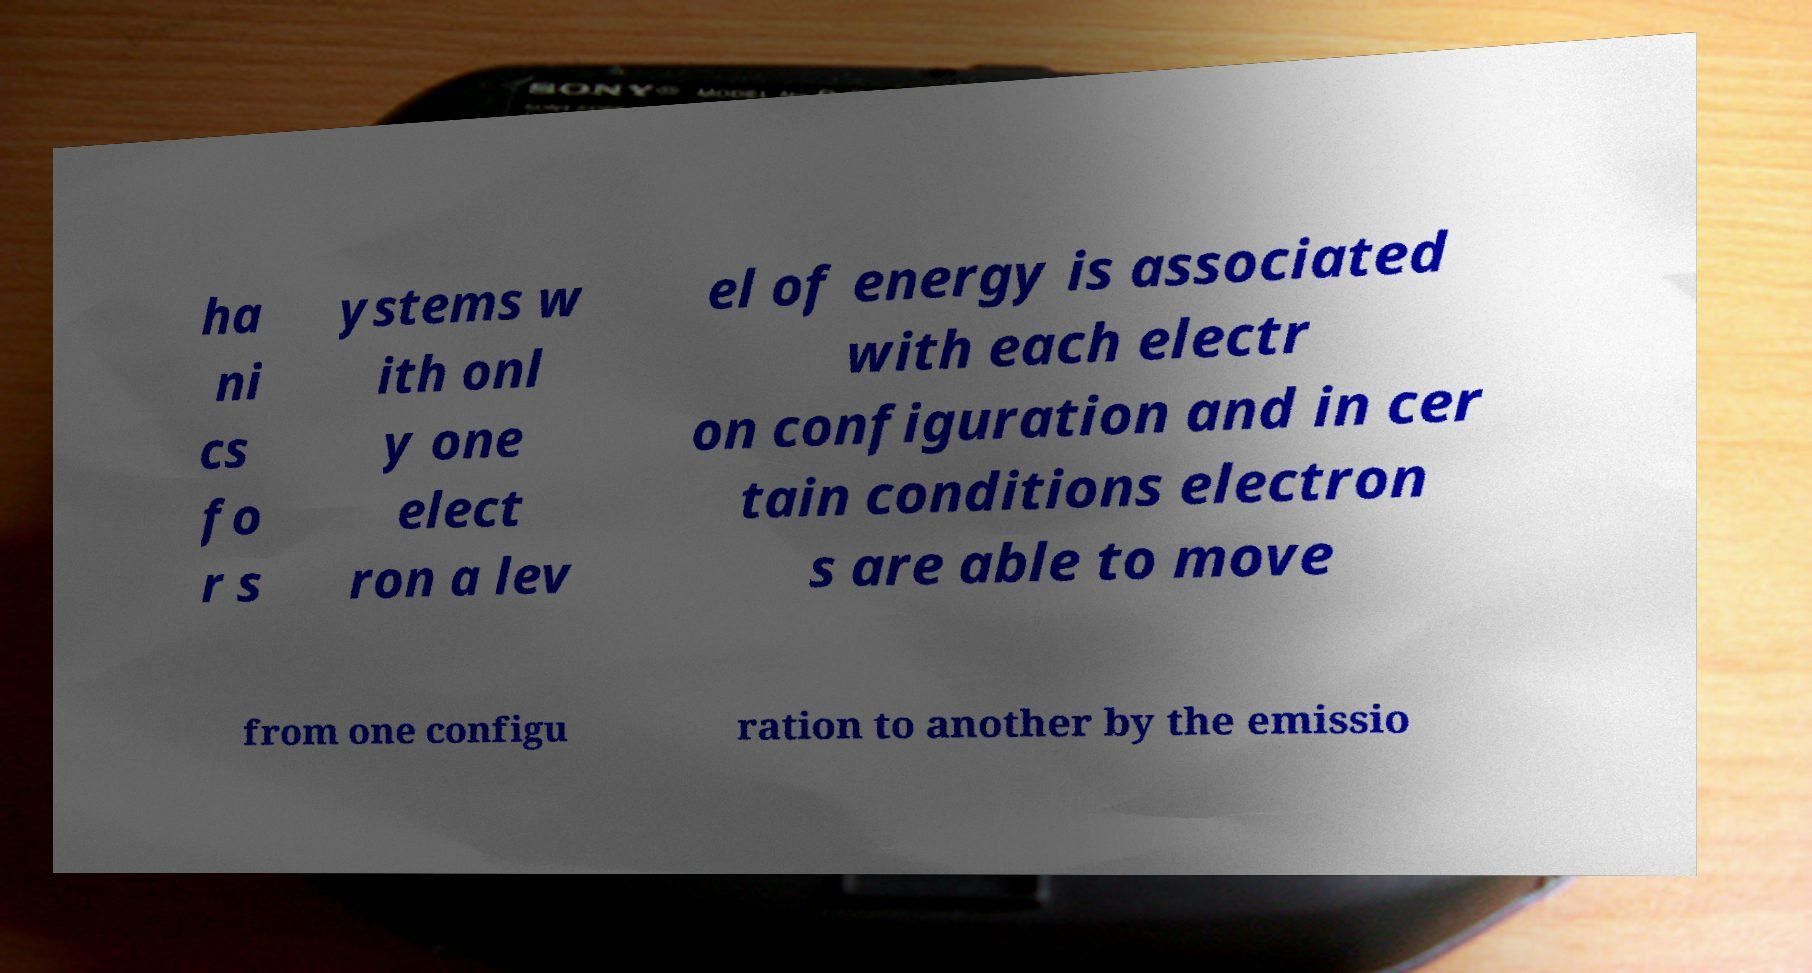What messages or text are displayed in this image? I need them in a readable, typed format. ha ni cs fo r s ystems w ith onl y one elect ron a lev el of energy is associated with each electr on configuration and in cer tain conditions electron s are able to move from one configu ration to another by the emissio 